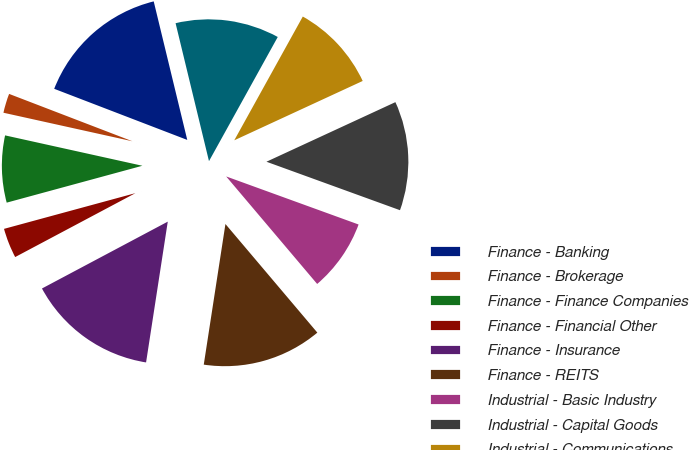<chart> <loc_0><loc_0><loc_500><loc_500><pie_chart><fcel>Finance - Banking<fcel>Finance - Brokerage<fcel>Finance - Finance Companies<fcel>Finance - Financial Other<fcel>Finance - Insurance<fcel>Finance - REITS<fcel>Industrial - Basic Industry<fcel>Industrial - Capital Goods<fcel>Industrial - Communications<fcel>Industrial - Consumer Cyclical<nl><fcel>15.38%<fcel>2.37%<fcel>7.69%<fcel>3.55%<fcel>14.79%<fcel>13.61%<fcel>8.28%<fcel>12.43%<fcel>10.06%<fcel>11.83%<nl></chart> 